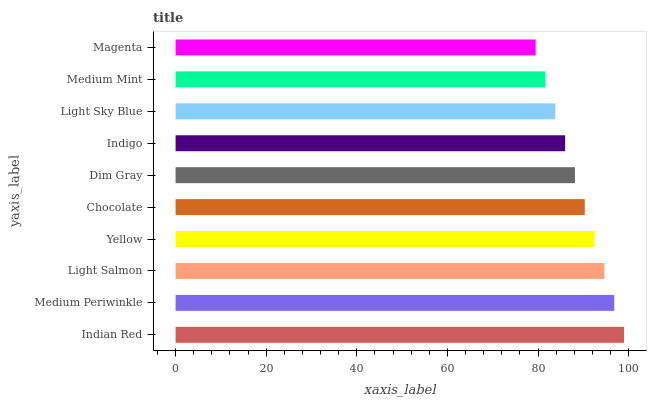Is Magenta the minimum?
Answer yes or no. Yes. Is Indian Red the maximum?
Answer yes or no. Yes. Is Medium Periwinkle the minimum?
Answer yes or no. No. Is Medium Periwinkle the maximum?
Answer yes or no. No. Is Indian Red greater than Medium Periwinkle?
Answer yes or no. Yes. Is Medium Periwinkle less than Indian Red?
Answer yes or no. Yes. Is Medium Periwinkle greater than Indian Red?
Answer yes or no. No. Is Indian Red less than Medium Periwinkle?
Answer yes or no. No. Is Chocolate the high median?
Answer yes or no. Yes. Is Dim Gray the low median?
Answer yes or no. Yes. Is Magenta the high median?
Answer yes or no. No. Is Medium Periwinkle the low median?
Answer yes or no. No. 